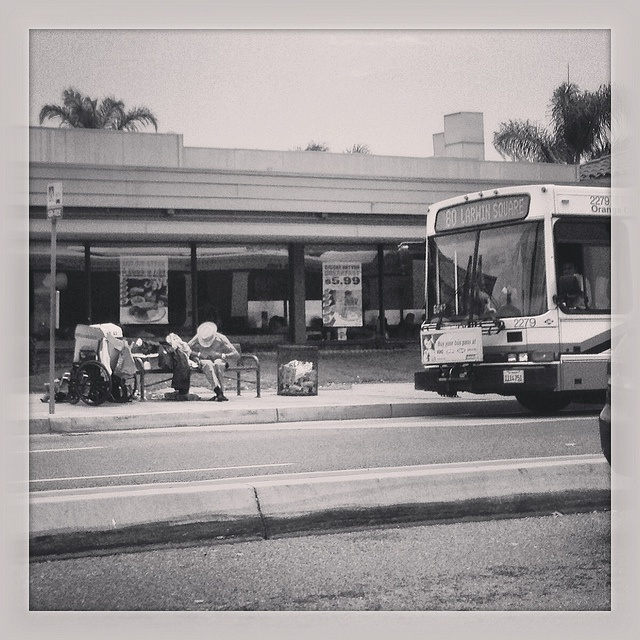Describe the objects in this image and their specific colors. I can see bus in lightgray, black, gray, and darkgray tones, people in lightgray, gray, darkgray, and black tones, people in lightgray, black, and gray tones, bench in lightgray, gray, and black tones, and bench in lightgray, gray, and black tones in this image. 